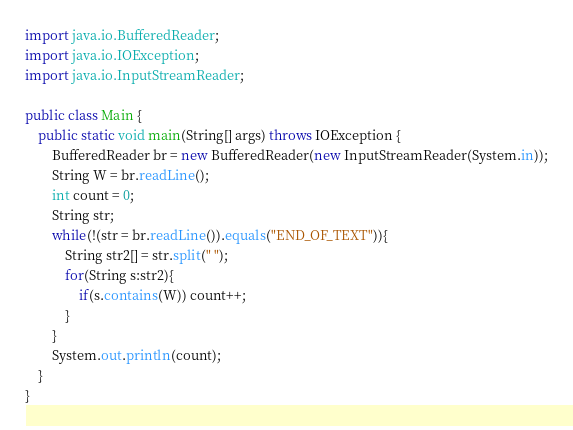<code> <loc_0><loc_0><loc_500><loc_500><_Java_>import java.io.BufferedReader;
import java.io.IOException;
import java.io.InputStreamReader;

public class Main {
    public static void main(String[] args) throws IOException {
        BufferedReader br = new BufferedReader(new InputStreamReader(System.in));
        String W = br.readLine();
        int count = 0;
        String str;
        while(!(str = br.readLine()).equals("END_OF_TEXT")){
            String str2[] = str.split(" ");
            for(String s:str2){
                if(s.contains(W)) count++;
            }
        }
        System.out.println(count);
    }
}</code> 